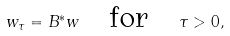Convert formula to latex. <formula><loc_0><loc_0><loc_500><loc_500>w _ { \tau } = { B ^ { \ast } } w \quad \text {for} \quad \tau > 0 ,</formula> 